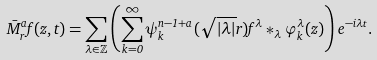Convert formula to latex. <formula><loc_0><loc_0><loc_500><loc_500>\bar { M } ^ { a } _ { r } f ( z , t ) = \sum _ { \lambda \in \mathbb { Z } } \left ( \sum ^ { \infty } _ { k = 0 } \psi ^ { n - 1 + a } _ { k } ( \sqrt { | \lambda | } r ) f ^ { \lambda } \ast _ { \lambda } \varphi ^ { \lambda } _ { k } ( z ) \right ) e ^ { - i \lambda t } .</formula> 